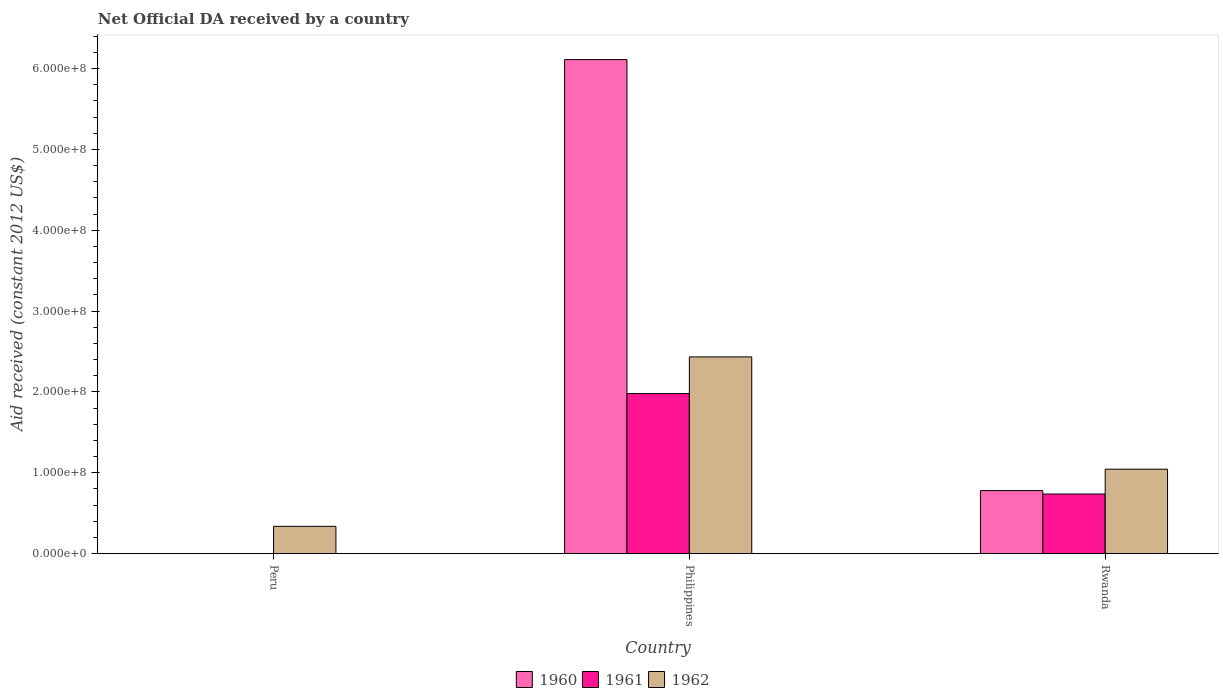Are the number of bars on each tick of the X-axis equal?
Provide a short and direct response. No. What is the label of the 1st group of bars from the left?
Your answer should be very brief. Peru. What is the net official development assistance aid received in 1960 in Rwanda?
Provide a succinct answer. 7.80e+07. Across all countries, what is the maximum net official development assistance aid received in 1961?
Provide a short and direct response. 1.98e+08. Across all countries, what is the minimum net official development assistance aid received in 1960?
Make the answer very short. 0. In which country was the net official development assistance aid received in 1960 maximum?
Keep it short and to the point. Philippines. What is the total net official development assistance aid received in 1962 in the graph?
Your answer should be very brief. 3.82e+08. What is the difference between the net official development assistance aid received in 1962 in Peru and that in Rwanda?
Provide a short and direct response. -7.07e+07. What is the difference between the net official development assistance aid received in 1961 in Peru and the net official development assistance aid received in 1960 in Philippines?
Provide a short and direct response. -6.11e+08. What is the average net official development assistance aid received in 1960 per country?
Provide a short and direct response. 2.30e+08. What is the difference between the net official development assistance aid received of/in 1961 and net official development assistance aid received of/in 1960 in Rwanda?
Keep it short and to the point. -4.24e+06. In how many countries, is the net official development assistance aid received in 1961 greater than 20000000 US$?
Ensure brevity in your answer.  2. What is the ratio of the net official development assistance aid received in 1960 in Philippines to that in Rwanda?
Provide a succinct answer. 7.84. Is the net official development assistance aid received in 1962 in Philippines less than that in Rwanda?
Offer a very short reply. No. Is the difference between the net official development assistance aid received in 1961 in Philippines and Rwanda greater than the difference between the net official development assistance aid received in 1960 in Philippines and Rwanda?
Provide a short and direct response. No. What is the difference between the highest and the second highest net official development assistance aid received in 1962?
Offer a very short reply. 2.10e+08. What is the difference between the highest and the lowest net official development assistance aid received in 1960?
Make the answer very short. 6.11e+08. In how many countries, is the net official development assistance aid received in 1962 greater than the average net official development assistance aid received in 1962 taken over all countries?
Your response must be concise. 1. Is the sum of the net official development assistance aid received in 1962 in Peru and Philippines greater than the maximum net official development assistance aid received in 1960 across all countries?
Ensure brevity in your answer.  No. Is it the case that in every country, the sum of the net official development assistance aid received in 1960 and net official development assistance aid received in 1961 is greater than the net official development assistance aid received in 1962?
Offer a terse response. No. How many bars are there?
Give a very brief answer. 7. Are all the bars in the graph horizontal?
Offer a terse response. No. How many countries are there in the graph?
Make the answer very short. 3. What is the difference between two consecutive major ticks on the Y-axis?
Your answer should be compact. 1.00e+08. Are the values on the major ticks of Y-axis written in scientific E-notation?
Offer a terse response. Yes. Does the graph contain grids?
Your answer should be compact. No. Where does the legend appear in the graph?
Ensure brevity in your answer.  Bottom center. What is the title of the graph?
Your answer should be very brief. Net Official DA received by a country. Does "2004" appear as one of the legend labels in the graph?
Your answer should be very brief. No. What is the label or title of the X-axis?
Make the answer very short. Country. What is the label or title of the Y-axis?
Ensure brevity in your answer.  Aid received (constant 2012 US$). What is the Aid received (constant 2012 US$) in 1960 in Peru?
Your response must be concise. 0. What is the Aid received (constant 2012 US$) of 1962 in Peru?
Your answer should be very brief. 3.38e+07. What is the Aid received (constant 2012 US$) in 1960 in Philippines?
Your answer should be very brief. 6.11e+08. What is the Aid received (constant 2012 US$) of 1961 in Philippines?
Ensure brevity in your answer.  1.98e+08. What is the Aid received (constant 2012 US$) of 1962 in Philippines?
Give a very brief answer. 2.43e+08. What is the Aid received (constant 2012 US$) in 1960 in Rwanda?
Offer a terse response. 7.80e+07. What is the Aid received (constant 2012 US$) in 1961 in Rwanda?
Keep it short and to the point. 7.38e+07. What is the Aid received (constant 2012 US$) in 1962 in Rwanda?
Offer a very short reply. 1.04e+08. Across all countries, what is the maximum Aid received (constant 2012 US$) in 1960?
Provide a short and direct response. 6.11e+08. Across all countries, what is the maximum Aid received (constant 2012 US$) of 1961?
Offer a very short reply. 1.98e+08. Across all countries, what is the maximum Aid received (constant 2012 US$) of 1962?
Keep it short and to the point. 2.43e+08. Across all countries, what is the minimum Aid received (constant 2012 US$) of 1960?
Provide a short and direct response. 0. Across all countries, what is the minimum Aid received (constant 2012 US$) in 1961?
Ensure brevity in your answer.  0. Across all countries, what is the minimum Aid received (constant 2012 US$) of 1962?
Provide a succinct answer. 3.38e+07. What is the total Aid received (constant 2012 US$) of 1960 in the graph?
Provide a short and direct response. 6.89e+08. What is the total Aid received (constant 2012 US$) of 1961 in the graph?
Provide a short and direct response. 2.72e+08. What is the total Aid received (constant 2012 US$) of 1962 in the graph?
Offer a very short reply. 3.82e+08. What is the difference between the Aid received (constant 2012 US$) of 1962 in Peru and that in Philippines?
Your response must be concise. -2.10e+08. What is the difference between the Aid received (constant 2012 US$) in 1962 in Peru and that in Rwanda?
Provide a succinct answer. -7.07e+07. What is the difference between the Aid received (constant 2012 US$) of 1960 in Philippines and that in Rwanda?
Make the answer very short. 5.33e+08. What is the difference between the Aid received (constant 2012 US$) of 1961 in Philippines and that in Rwanda?
Provide a succinct answer. 1.24e+08. What is the difference between the Aid received (constant 2012 US$) in 1962 in Philippines and that in Rwanda?
Your response must be concise. 1.39e+08. What is the difference between the Aid received (constant 2012 US$) in 1960 in Philippines and the Aid received (constant 2012 US$) in 1961 in Rwanda?
Ensure brevity in your answer.  5.37e+08. What is the difference between the Aid received (constant 2012 US$) of 1960 in Philippines and the Aid received (constant 2012 US$) of 1962 in Rwanda?
Ensure brevity in your answer.  5.07e+08. What is the difference between the Aid received (constant 2012 US$) in 1961 in Philippines and the Aid received (constant 2012 US$) in 1962 in Rwanda?
Your answer should be very brief. 9.36e+07. What is the average Aid received (constant 2012 US$) of 1960 per country?
Give a very brief answer. 2.30e+08. What is the average Aid received (constant 2012 US$) of 1961 per country?
Your answer should be very brief. 9.06e+07. What is the average Aid received (constant 2012 US$) of 1962 per country?
Provide a succinct answer. 1.27e+08. What is the difference between the Aid received (constant 2012 US$) of 1960 and Aid received (constant 2012 US$) of 1961 in Philippines?
Give a very brief answer. 4.13e+08. What is the difference between the Aid received (constant 2012 US$) in 1960 and Aid received (constant 2012 US$) in 1962 in Philippines?
Ensure brevity in your answer.  3.68e+08. What is the difference between the Aid received (constant 2012 US$) of 1961 and Aid received (constant 2012 US$) of 1962 in Philippines?
Ensure brevity in your answer.  -4.53e+07. What is the difference between the Aid received (constant 2012 US$) of 1960 and Aid received (constant 2012 US$) of 1961 in Rwanda?
Give a very brief answer. 4.24e+06. What is the difference between the Aid received (constant 2012 US$) in 1960 and Aid received (constant 2012 US$) in 1962 in Rwanda?
Offer a very short reply. -2.65e+07. What is the difference between the Aid received (constant 2012 US$) in 1961 and Aid received (constant 2012 US$) in 1962 in Rwanda?
Provide a succinct answer. -3.07e+07. What is the ratio of the Aid received (constant 2012 US$) in 1962 in Peru to that in Philippines?
Offer a terse response. 0.14. What is the ratio of the Aid received (constant 2012 US$) in 1962 in Peru to that in Rwanda?
Give a very brief answer. 0.32. What is the ratio of the Aid received (constant 2012 US$) of 1960 in Philippines to that in Rwanda?
Make the answer very short. 7.84. What is the ratio of the Aid received (constant 2012 US$) in 1961 in Philippines to that in Rwanda?
Give a very brief answer. 2.69. What is the ratio of the Aid received (constant 2012 US$) in 1962 in Philippines to that in Rwanda?
Offer a terse response. 2.33. What is the difference between the highest and the second highest Aid received (constant 2012 US$) of 1962?
Make the answer very short. 1.39e+08. What is the difference between the highest and the lowest Aid received (constant 2012 US$) of 1960?
Offer a very short reply. 6.11e+08. What is the difference between the highest and the lowest Aid received (constant 2012 US$) in 1961?
Provide a succinct answer. 1.98e+08. What is the difference between the highest and the lowest Aid received (constant 2012 US$) in 1962?
Make the answer very short. 2.10e+08. 